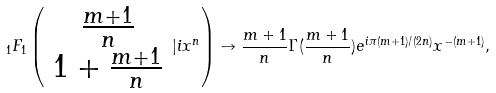<formula> <loc_0><loc_0><loc_500><loc_500>\, _ { 1 } F _ { 1 } \left ( \begin{array} { c } \frac { m + 1 } { n } \\ 1 + \frac { m + 1 } { n } \end{array} | i x ^ { n } \right ) \to \frac { m + 1 } { n } \Gamma ( \frac { m + 1 } { n } ) e ^ { i \pi ( m + 1 ) / ( 2 n ) } x ^ { - ( m + 1 ) } ,</formula> 